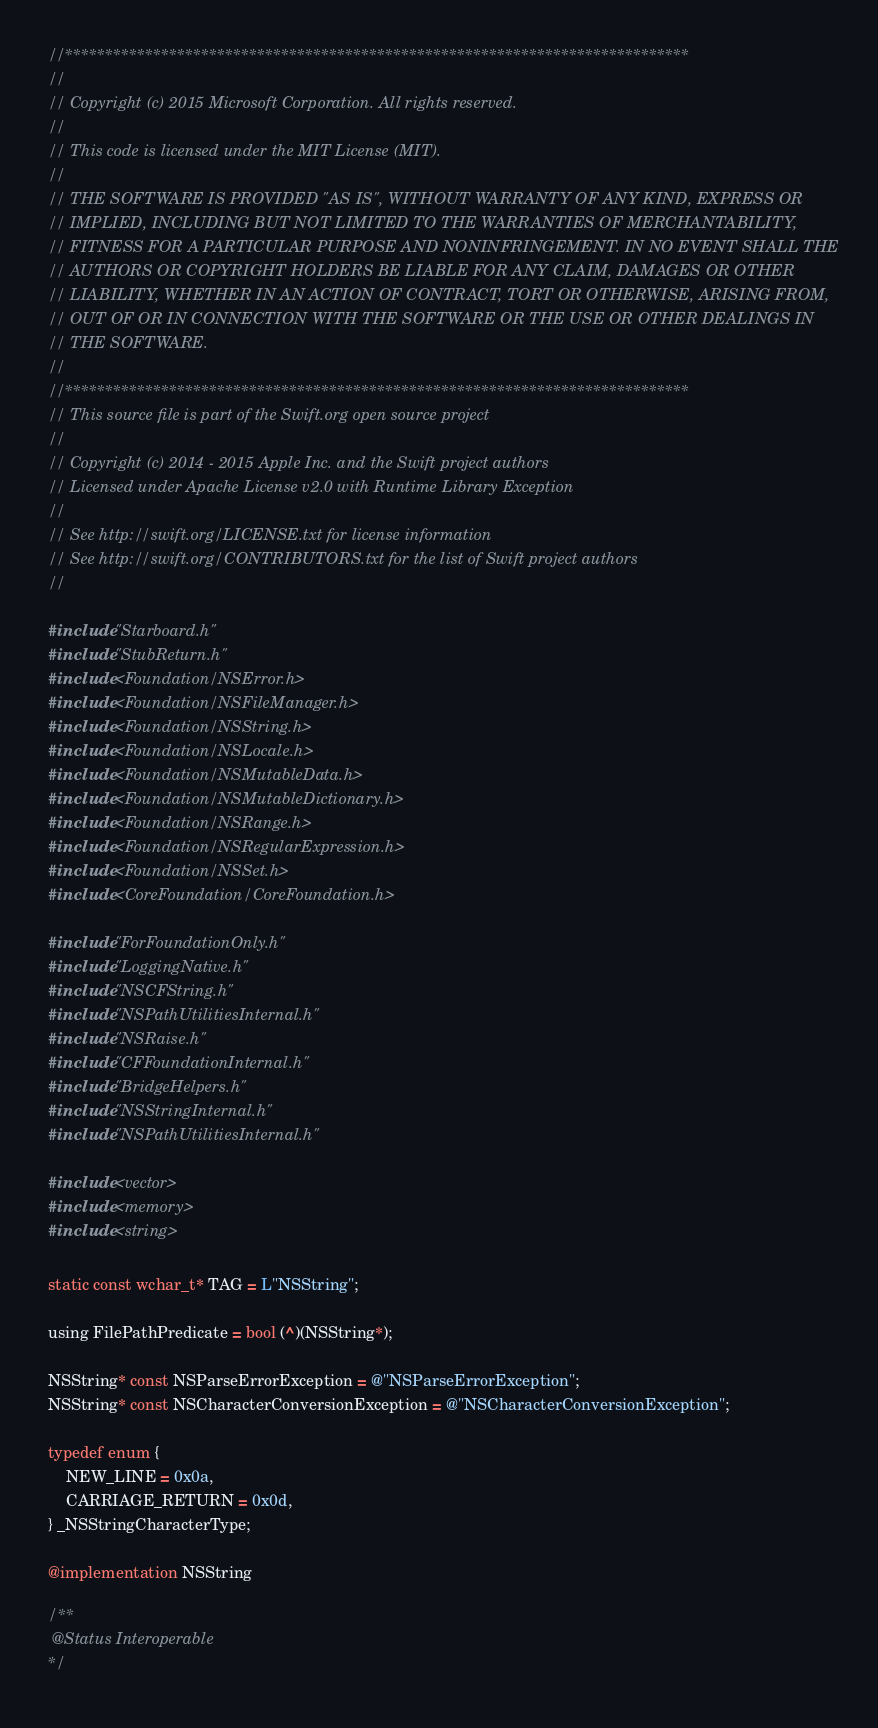<code> <loc_0><loc_0><loc_500><loc_500><_ObjectiveC_>//******************************************************************************
//
// Copyright (c) 2015 Microsoft Corporation. All rights reserved.
//
// This code is licensed under the MIT License (MIT).
//
// THE SOFTWARE IS PROVIDED "AS IS", WITHOUT WARRANTY OF ANY KIND, EXPRESS OR
// IMPLIED, INCLUDING BUT NOT LIMITED TO THE WARRANTIES OF MERCHANTABILITY,
// FITNESS FOR A PARTICULAR PURPOSE AND NONINFRINGEMENT. IN NO EVENT SHALL THE
// AUTHORS OR COPYRIGHT HOLDERS BE LIABLE FOR ANY CLAIM, DAMAGES OR OTHER
// LIABILITY, WHETHER IN AN ACTION OF CONTRACT, TORT OR OTHERWISE, ARISING FROM,
// OUT OF OR IN CONNECTION WITH THE SOFTWARE OR THE USE OR OTHER DEALINGS IN
// THE SOFTWARE.
//
//******************************************************************************
// This source file is part of the Swift.org open source project
//
// Copyright (c) 2014 - 2015 Apple Inc. and the Swift project authors
// Licensed under Apache License v2.0 with Runtime Library Exception
//
// See http://swift.org/LICENSE.txt for license information
// See http://swift.org/CONTRIBUTORS.txt for the list of Swift project authors
//

#include "Starboard.h"
#include "StubReturn.h"
#include <Foundation/NSError.h>
#include <Foundation/NSFileManager.h>
#include <Foundation/NSString.h>
#include <Foundation/NSLocale.h>
#include <Foundation/NSMutableData.h>
#include <Foundation/NSMutableDictionary.h>
#include <Foundation/NSRange.h>
#include <Foundation/NSRegularExpression.h>
#include <Foundation/NSSet.h>
#include <CoreFoundation/CoreFoundation.h>

#include "ForFoundationOnly.h"
#include "LoggingNative.h"
#include "NSCFString.h"
#include "NSPathUtilitiesInternal.h"
#include "NSRaise.h"
#include "CFFoundationInternal.h"
#include "BridgeHelpers.h"
#include "NSStringInternal.h"
#include "NSPathUtilitiesInternal.h"

#include <vector>
#include <memory>
#include <string>

static const wchar_t* TAG = L"NSString";

using FilePathPredicate = bool (^)(NSString*);

NSString* const NSParseErrorException = @"NSParseErrorException";
NSString* const NSCharacterConversionException = @"NSCharacterConversionException";

typedef enum {
    NEW_LINE = 0x0a,
    CARRIAGE_RETURN = 0x0d,
} _NSStringCharacterType;

@implementation NSString

/**
 @Status Interoperable
*/</code> 